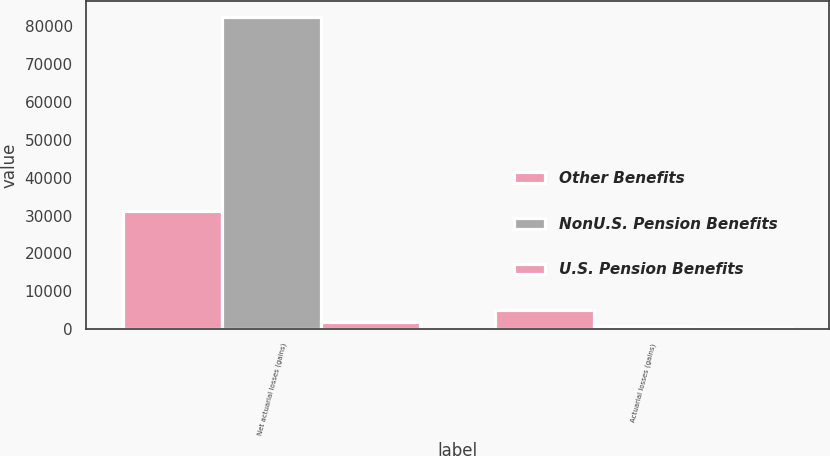<chart> <loc_0><loc_0><loc_500><loc_500><stacked_bar_chart><ecel><fcel>Net actuarial losses (gains)<fcel>Actuarial losses (gains)<nl><fcel>Other Benefits<fcel>31101<fcel>5103<nl><fcel>NonU.S. Pension Benefits<fcel>82427<fcel>845<nl><fcel>U.S. Pension Benefits<fcel>1971<fcel>693<nl></chart> 